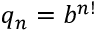Convert formula to latex. <formula><loc_0><loc_0><loc_500><loc_500>q _ { n } = b ^ { n ! }</formula> 